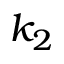<formula> <loc_0><loc_0><loc_500><loc_500>k _ { 2 }</formula> 